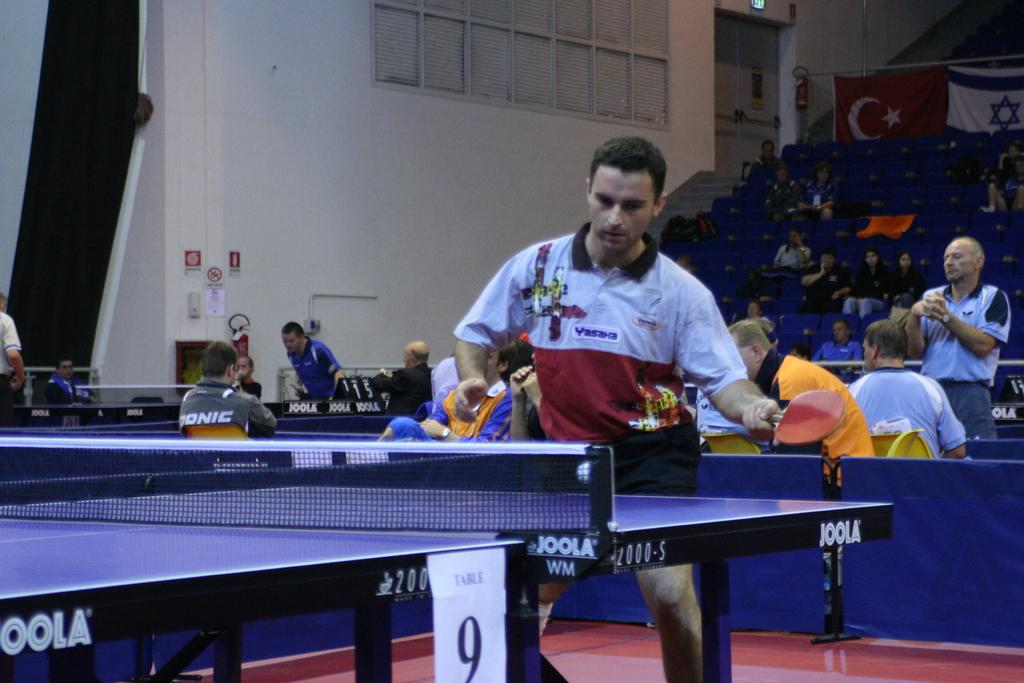What activity is the person in the image engaged in? The person is playing table tennis in the image. Are there any spectators present in the image? Yes, there is an audience in the image. What is the audience doing during the game? The audience is encouraging the player. Where is the game taking place? It is taking place in a court. What is a key feature of a table tennis court? There is a net in the court. What equipment is being used to play table tennis? A bat is being used to play table tennis. Is there any symbol of nationality visible in the image? Yes, there is a flag of a country visible in the image. Can you see any clouds in the image? No, there are no clouds visible in the image. 